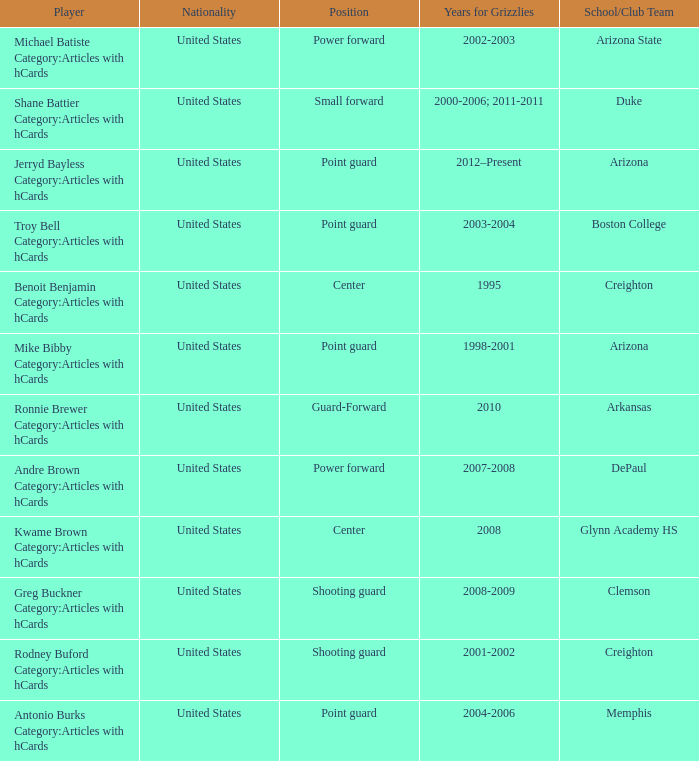Give me the full table as a dictionary. {'header': ['Player', 'Nationality', 'Position', 'Years for Grizzlies', 'School/Club Team'], 'rows': [['Michael Batiste Category:Articles with hCards', 'United States', 'Power forward', '2002-2003', 'Arizona State'], ['Shane Battier Category:Articles with hCards', 'United States', 'Small forward', '2000-2006; 2011-2011', 'Duke'], ['Jerryd Bayless Category:Articles with hCards', 'United States', 'Point guard', '2012–Present', 'Arizona'], ['Troy Bell Category:Articles with hCards', 'United States', 'Point guard', '2003-2004', 'Boston College'], ['Benoit Benjamin Category:Articles with hCards', 'United States', 'Center', '1995', 'Creighton'], ['Mike Bibby Category:Articles with hCards', 'United States', 'Point guard', '1998-2001', 'Arizona'], ['Ronnie Brewer Category:Articles with hCards', 'United States', 'Guard-Forward', '2010', 'Arkansas'], ['Andre Brown Category:Articles with hCards', 'United States', 'Power forward', '2007-2008', 'DePaul'], ['Kwame Brown Category:Articles with hCards', 'United States', 'Center', '2008', 'Glynn Academy HS'], ['Greg Buckner Category:Articles with hCards', 'United States', 'Shooting guard', '2008-2009', 'Clemson'], ['Rodney Buford Category:Articles with hCards', 'United States', 'Shooting guard', '2001-2002', 'Creighton'], ['Antonio Burks Category:Articles with hCards', 'United States', 'Point guard', '2004-2006', 'Memphis']]} Who played for the grizzlies between 2002 and 2003? Michael Batiste Category:Articles with hCards. 